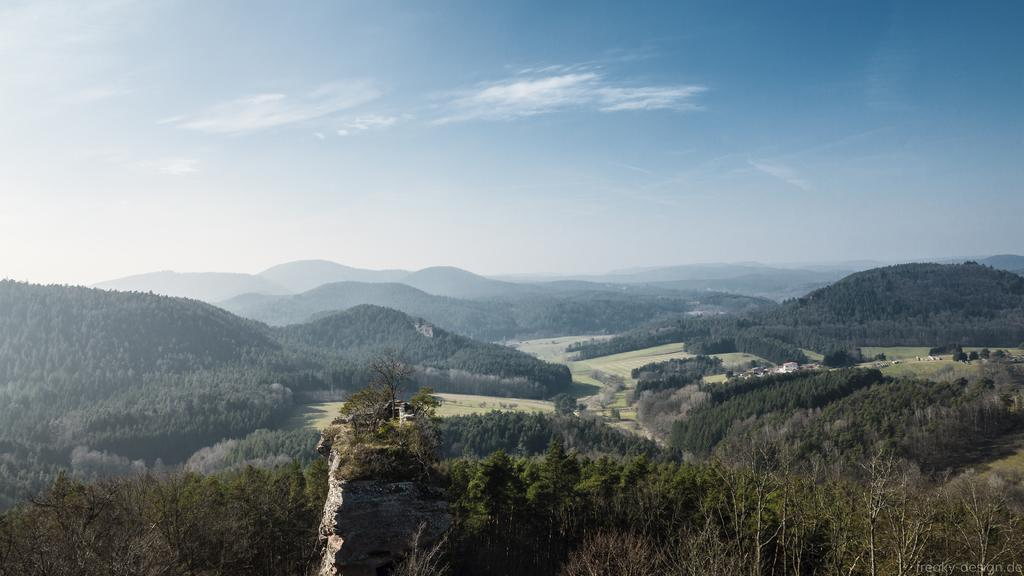What type of view is shown in the image? The image is an aerial view. What natural elements can be seen in the image? There are trees and hills visible in the image. What else is visible in the image besides the natural elements? The sky is visible in the image. What type of creature can be seen playing with a pet in the image? There are no creatures or pets present in the image; it is an aerial view of trees, hills, and the sky. 